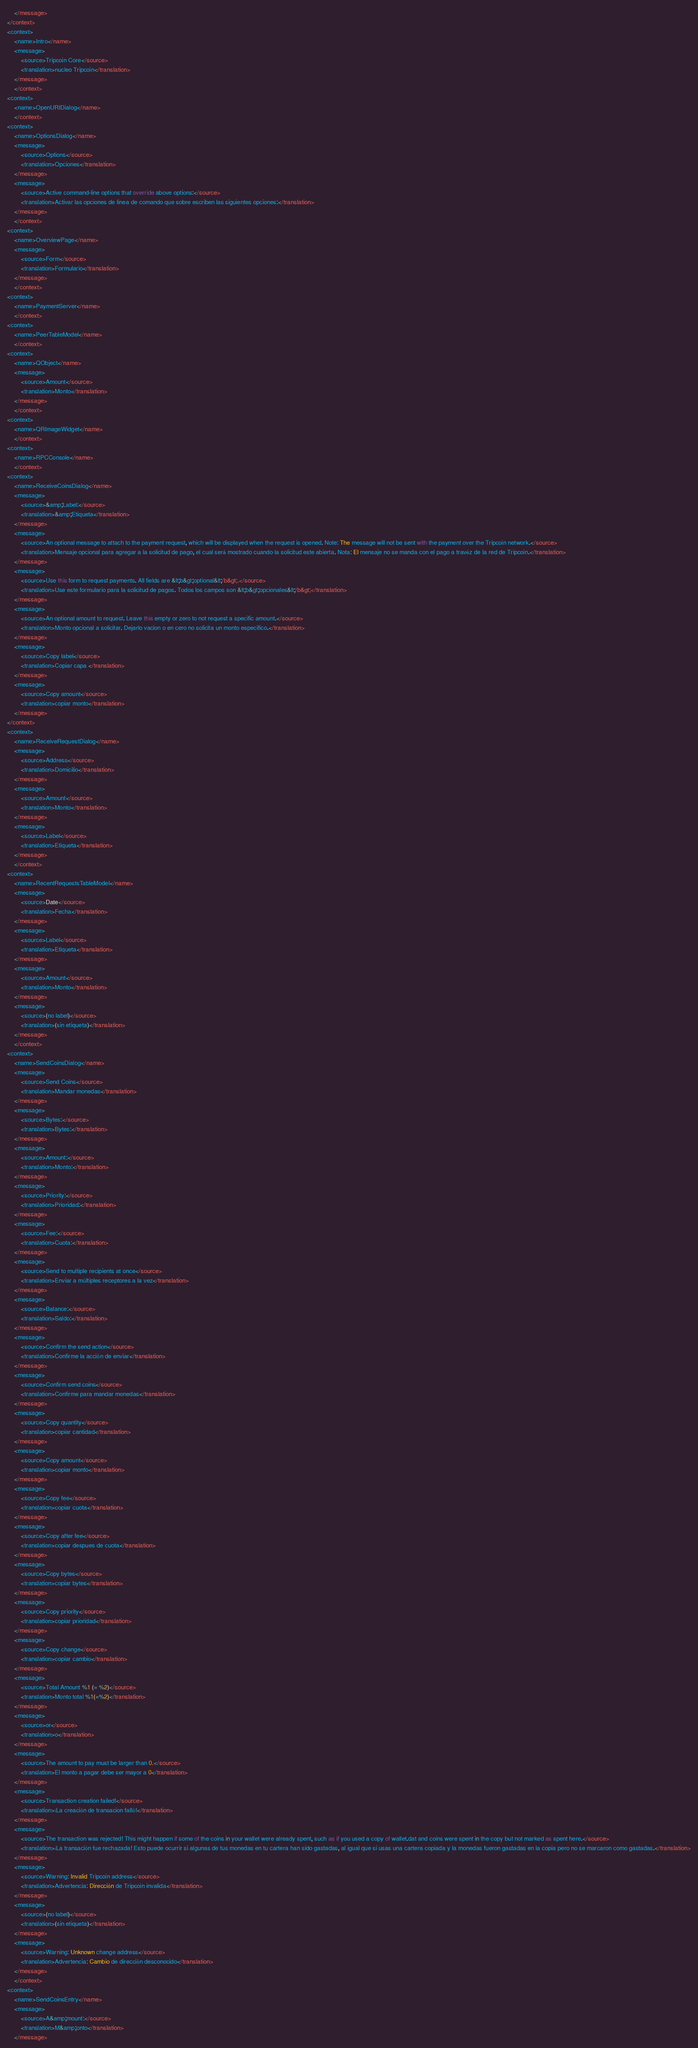<code> <loc_0><loc_0><loc_500><loc_500><_TypeScript_>    </message>
</context>
<context>
    <name>Intro</name>
    <message>
        <source>Tripcoin Core</source>
        <translation>nucleo Tripcoin</translation>
    </message>
    </context>
<context>
    <name>OpenURIDialog</name>
    </context>
<context>
    <name>OptionsDialog</name>
    <message>
        <source>Options</source>
        <translation>Opciones</translation>
    </message>
    <message>
        <source>Active command-line options that override above options:</source>
        <translation>Activar las opciones de linea de comando que sobre escriben las siguientes opciones:</translation>
    </message>
    </context>
<context>
    <name>OverviewPage</name>
    <message>
        <source>Form</source>
        <translation>Formulario</translation>
    </message>
    </context>
<context>
    <name>PaymentServer</name>
    </context>
<context>
    <name>PeerTableModel</name>
    </context>
<context>
    <name>QObject</name>
    <message>
        <source>Amount</source>
        <translation>Monto</translation>
    </message>
    </context>
<context>
    <name>QRImageWidget</name>
    </context>
<context>
    <name>RPCConsole</name>
    </context>
<context>
    <name>ReceiveCoinsDialog</name>
    <message>
        <source>&amp;Label:</source>
        <translation>&amp;Etiqueta</translation>
    </message>
    <message>
        <source>An optional message to attach to the payment request, which will be displayed when the request is opened. Note: The message will not be sent with the payment over the Tripcoin network.</source>
        <translation>Mensaje opcional para agregar a la solicitud de pago, el cual será mostrado cuando la solicitud este abierta. Nota: El mensaje no se manda con el pago a travéz de la red de Tripcoin.</translation>
    </message>
    <message>
        <source>Use this form to request payments. All fields are &lt;b&gt;optional&lt;/b&gt;.</source>
        <translation>Use este formulario para la solicitud de pagos. Todos los campos son &lt;b&gt;opcionales&lt;/b&gt;</translation>
    </message>
    <message>
        <source>An optional amount to request. Leave this empty or zero to not request a specific amount.</source>
        <translation>Monto opcional a solicitar. Dejarlo vacion o en cero no solicita un monto especifico.</translation>
    </message>
    <message>
        <source>Copy label</source>
        <translation>Copiar capa </translation>
    </message>
    <message>
        <source>Copy amount</source>
        <translation>copiar monto</translation>
    </message>
</context>
<context>
    <name>ReceiveRequestDialog</name>
    <message>
        <source>Address</source>
        <translation>Domicilio</translation>
    </message>
    <message>
        <source>Amount</source>
        <translation>Monto</translation>
    </message>
    <message>
        <source>Label</source>
        <translation>Etiqueta</translation>
    </message>
    </context>
<context>
    <name>RecentRequestsTableModel</name>
    <message>
        <source>Date</source>
        <translation>Fecha</translation>
    </message>
    <message>
        <source>Label</source>
        <translation>Etiqueta</translation>
    </message>
    <message>
        <source>Amount</source>
        <translation>Monto</translation>
    </message>
    <message>
        <source>(no label)</source>
        <translation>(sin etiqueta)</translation>
    </message>
    </context>
<context>
    <name>SendCoinsDialog</name>
    <message>
        <source>Send Coins</source>
        <translation>Mandar monedas</translation>
    </message>
    <message>
        <source>Bytes:</source>
        <translation>Bytes:</translation>
    </message>
    <message>
        <source>Amount:</source>
        <translation>Monto:</translation>
    </message>
    <message>
        <source>Priority:</source>
        <translation>Prioridad:</translation>
    </message>
    <message>
        <source>Fee:</source>
        <translation>Cuota:</translation>
    </message>
    <message>
        <source>Send to multiple recipients at once</source>
        <translation>Enviar a múltiples receptores a la vez</translation>
    </message>
    <message>
        <source>Balance:</source>
        <translation>Saldo:</translation>
    </message>
    <message>
        <source>Confirm the send action</source>
        <translation>Confirme la acción de enviar</translation>
    </message>
    <message>
        <source>Confirm send coins</source>
        <translation>Confirme para mandar monedas</translation>
    </message>
    <message>
        <source>Copy quantity</source>
        <translation>copiar cantidad</translation>
    </message>
    <message>
        <source>Copy amount</source>
        <translation>copiar monto</translation>
    </message>
    <message>
        <source>Copy fee</source>
        <translation>copiar cuota</translation>
    </message>
    <message>
        <source>Copy after fee</source>
        <translation>copiar despues de cuota</translation>
    </message>
    <message>
        <source>Copy bytes</source>
        <translation>copiar bytes</translation>
    </message>
    <message>
        <source>Copy priority</source>
        <translation>copiar prioridad</translation>
    </message>
    <message>
        <source>Copy change</source>
        <translation>copiar cambio</translation>
    </message>
    <message>
        <source>Total Amount %1 (= %2)</source>
        <translation>Monto total %1(=%2)</translation>
    </message>
    <message>
        <source>or</source>
        <translation>o</translation>
    </message>
    <message>
        <source>The amount to pay must be larger than 0.</source>
        <translation>El monto a pagar debe ser mayor a 0</translation>
    </message>
    <message>
        <source>Transaction creation failed!</source>
        <translation>¡La creación de transacion falló!</translation>
    </message>
    <message>
        <source>The transaction was rejected! This might happen if some of the coins in your wallet were already spent, such as if you used a copy of wallet.dat and coins were spent in the copy but not marked as spent here.</source>
        <translation>¡La transación fue rechazada! Esto puede ocurrir si algunas de tus monedas en tu cartera han sido gastadas, al igual que si usas una cartera copiada y la monedas fueron gastadas en la copia pero no se marcaron como gastadas.</translation>
    </message>
    <message>
        <source>Warning: Invalid Tripcoin address</source>
        <translation>Advertencia: Dirección de Tripcoin invalida</translation>
    </message>
    <message>
        <source>(no label)</source>
        <translation>(sin etiqueta)</translation>
    </message>
    <message>
        <source>Warning: Unknown change address</source>
        <translation>Advertencia: Cambio de dirección desconocido</translation>
    </message>
    </context>
<context>
    <name>SendCoinsEntry</name>
    <message>
        <source>A&amp;mount:</source>
        <translation>M&amp;onto</translation>
    </message></code> 